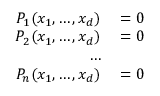Convert formula to latex. <formula><loc_0><loc_0><loc_500><loc_500>\begin{array} { r l } { P _ { 1 } ( x _ { 1 } , \dots , x _ { d } ) } & = 0 } \\ { P _ { 2 } ( x _ { 1 } , \dots , x _ { d } ) } & = 0 } \\ { \dots } \\ { P _ { n } ( x _ { 1 } , \dots , x _ { d } ) } & = 0 } \end{array}</formula> 